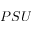<formula> <loc_0><loc_0><loc_500><loc_500>P S U</formula> 